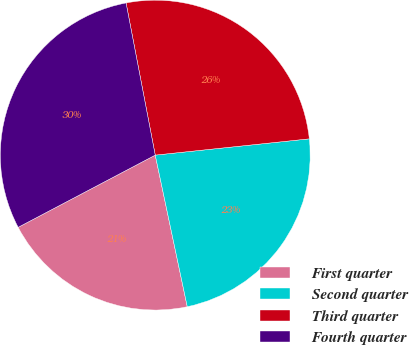Convert chart. <chart><loc_0><loc_0><loc_500><loc_500><pie_chart><fcel>First quarter<fcel>Second quarter<fcel>Third quarter<fcel>Fourth quarter<nl><fcel>20.6%<fcel>23.36%<fcel>26.34%<fcel>29.7%<nl></chart> 